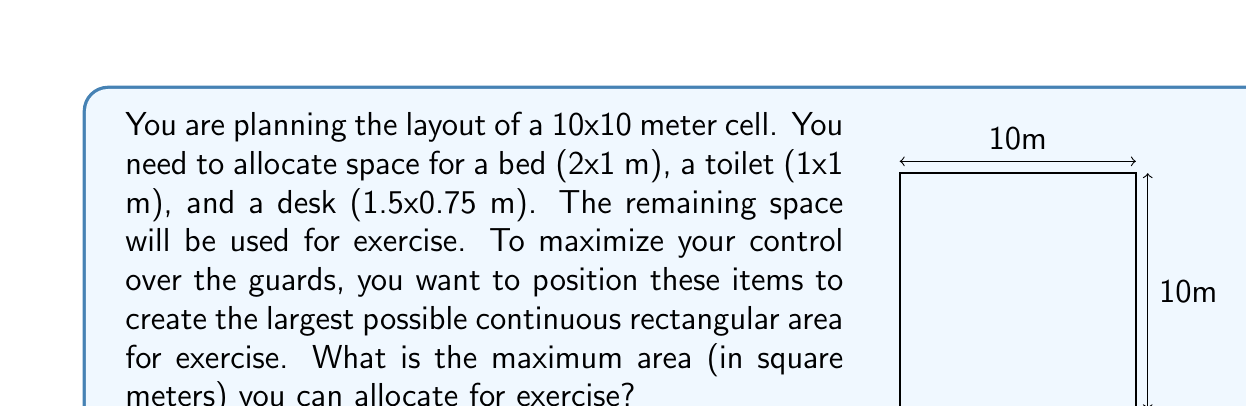Teach me how to tackle this problem. Let's approach this step-by-step:

1) The total area of the cell is 100 m².

2) The areas of the fixed items are:
   - Bed: 2 * 1 = 2 m²
   - Toilet: 1 * 1 = 1 m²
   - Desk: 1.5 * 0.75 = 1.125 m²

3) Total area of fixed items: 2 + 1 + 1.125 = 4.125 m²

4) To maximize the continuous rectangular area for exercise, we need to place all items along the walls.

5) The most efficient arrangement is to place the bed and toilet along one wall, and the desk along another wall adjacent to it.

6) This creates an L-shaped occupied area, leaving a large rectangular area for exercise.

7) The dimensions of this exercise area will be:
   - Width: 10 - 1.5 = 8.5 m (subtracting desk width)
   - Height: 10 - 2 = 8 m (subtracting bed length)

8) The area of the exercise space is therefore:
   $$ A = 8.5 * 8 = 68 \text{ m}^2 $$

This arrangement maximizes the continuous rectangular area for exercise.
Answer: 68 m² 